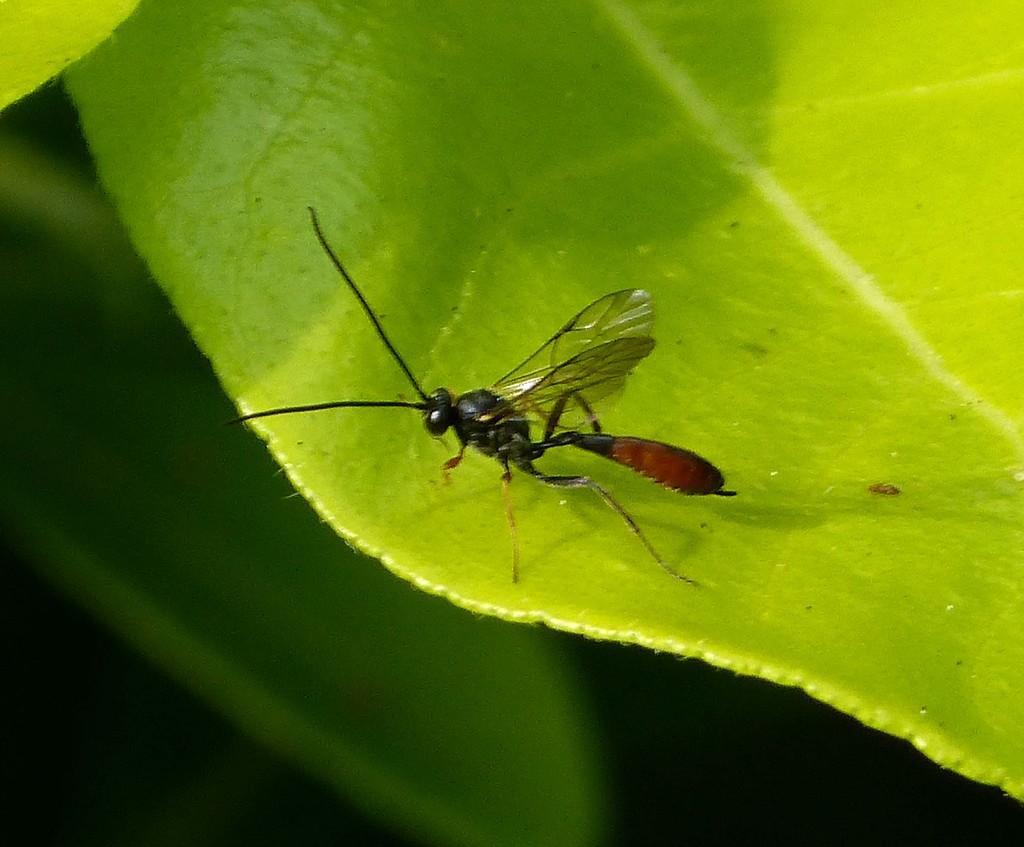Please provide a concise description of this image. We can see insect on leaf. Bottom it is dark and we can see green leaf. 